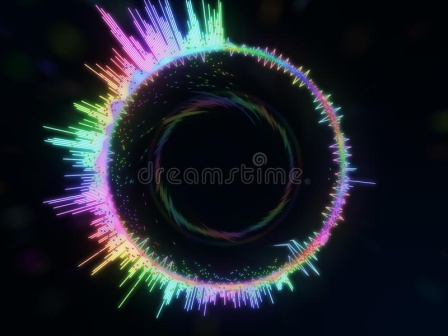Imagine this image represents a portal to another dimension. What kind of world would this portal lead to? If this image were a portal to another dimension, stepping through it could transport you to an ethereal world where the laws of physics as we know them do not apply. You might find yourself in a realm filled with vibrant, swirling energies, much like the aura depicted around the black hole. This world might be composed of luminescent landscapes that constantly shift in shape and color, reflecting the dynamic and fluid nature of the portal itself. Inhabitants of this dimension could be beings of pure energy, able to manipulate the environment with their thoughts. Entire ecosystems could exist in a state of perpetual motion, with plants and creatures that emit radiant light instead of relying on the sun. This dimension would be a place of endless wonder and discovery, where the boundaries of time and space are fluid and ever-changing. 